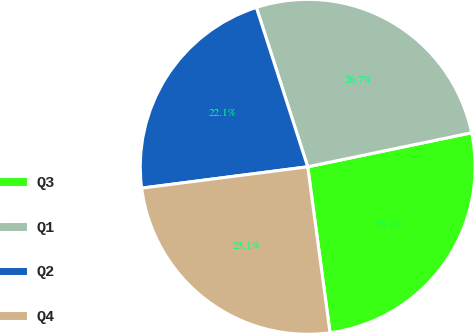Convert chart. <chart><loc_0><loc_0><loc_500><loc_500><pie_chart><fcel>Q3<fcel>Q1<fcel>Q2<fcel>Q4<nl><fcel>26.13%<fcel>26.7%<fcel>22.07%<fcel>25.09%<nl></chart> 